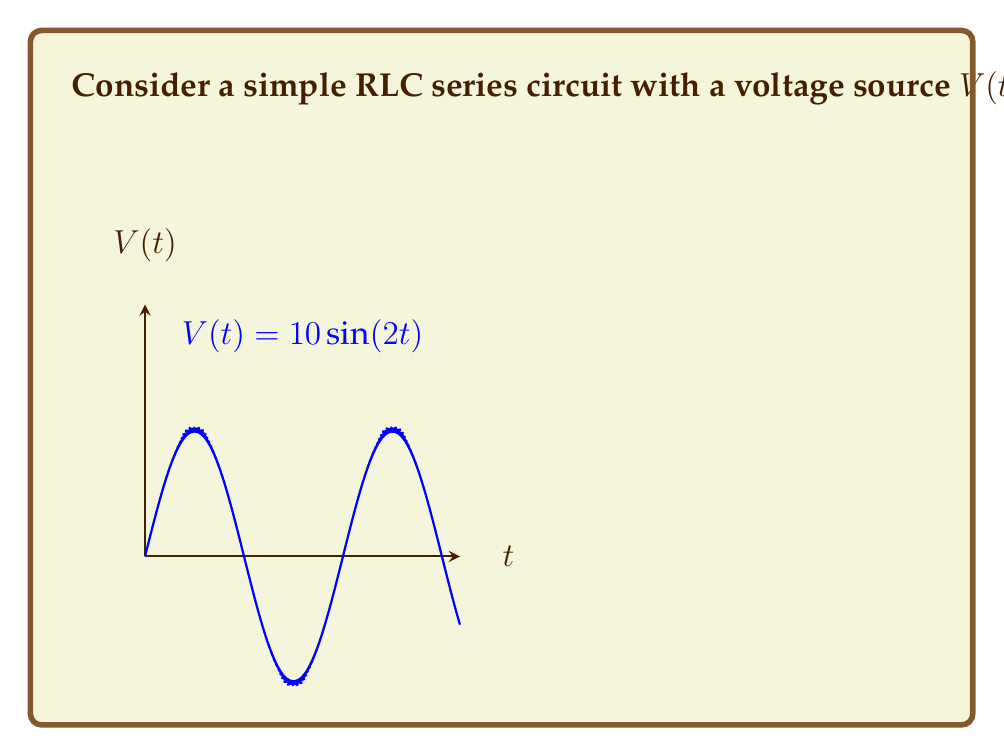Provide a solution to this math problem. Let's solve this problem step by step using the Laplace transform method:

1) First, we need to write the differential equation for the circuit:

   $$L\frac{d^2i}{dt^2} + R\frac{di}{dt} + \frac{1}{C}i = V(t)$$

2) Now, let's take the Laplace transform of both sides:

   $$L[L\frac{d^2i}{dt^2} + R\frac{di}{dt} + \frac{1}{C}i] = L[10\sin(2t)]$$

3) Using Laplace transform properties:

   $$L[s^2I(s) - si(0) - i'(0)] + R[sI(s) - i(0)] + \frac{1}{C}I(s) = \frac{20}{s^2 + 4}$$

   Assuming initial conditions are zero (i(0) = i'(0) = 0):

   $$Ls^2I(s) + RsI(s) + \frac{1}{C}I(s) = \frac{20}{s^2 + 4}$$

4) Factor out I(s):

   $$I(s)(Ls^2 + Rs + \frac{1}{C}) = \frac{20}{s^2 + 4}$$

5) Solve for I(s):

   $$I(s) = \frac{20}{(s^2 + 4)(Ls^2 + Rs + \frac{1}{C})}$$

6) Substitute the given values:

   $$I(s) = \frac{20}{(s^2 + 4)(0.5s^2 + 2s + 10)}$$

7) For steady-state response, we're only interested in the particular solution, which corresponds to the terms with $s^2 + 4$ in the denominator. The other terms will decay over time. So:

   $$I(s) \approx \frac{20}{(s^2 + 4)(10)} = \frac{2}{s^2 + 4}$$

8) The inverse Laplace transform of this is:

   $$i(t) = 2\sin(2t)$$

This is the steady-state current in the circuit.
Answer: $i(t) = 2\sin(2t)$ A 